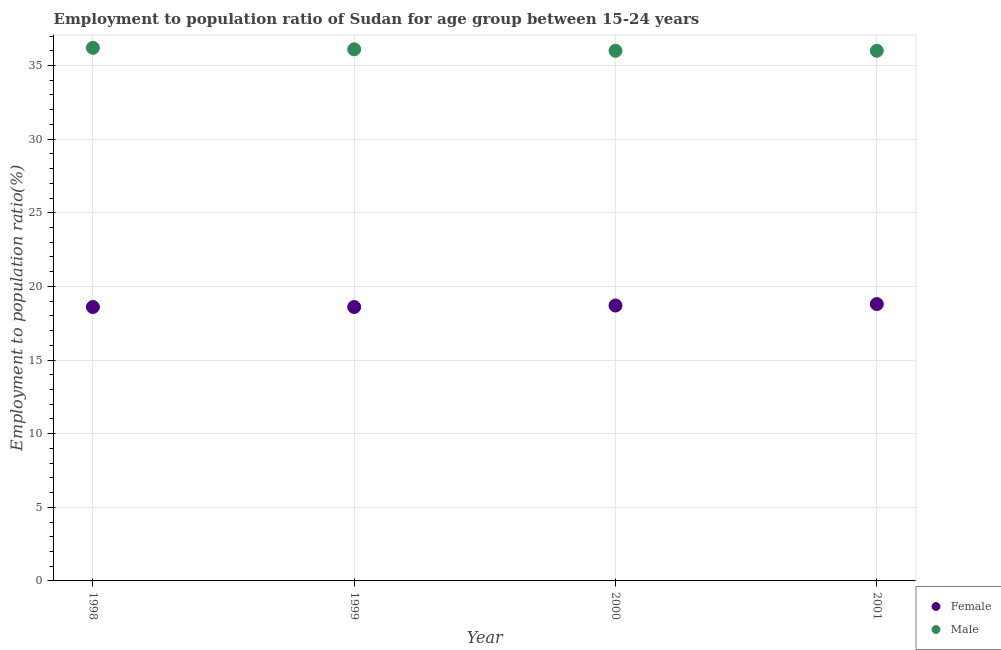How many different coloured dotlines are there?
Your response must be concise. 2. Is the number of dotlines equal to the number of legend labels?
Keep it short and to the point. Yes. What is the employment to population ratio(male) in 1999?
Your answer should be very brief. 36.1. Across all years, what is the maximum employment to population ratio(male)?
Make the answer very short. 36.2. Across all years, what is the minimum employment to population ratio(female)?
Keep it short and to the point. 18.6. What is the total employment to population ratio(male) in the graph?
Offer a very short reply. 144.3. What is the difference between the employment to population ratio(male) in 1999 and that in 2000?
Offer a very short reply. 0.1. What is the difference between the employment to population ratio(female) in 2001 and the employment to population ratio(male) in 2000?
Your answer should be very brief. -17.2. What is the average employment to population ratio(female) per year?
Offer a terse response. 18.68. In the year 2001, what is the difference between the employment to population ratio(male) and employment to population ratio(female)?
Your answer should be very brief. 17.2. What is the ratio of the employment to population ratio(female) in 1998 to that in 2000?
Your response must be concise. 0.99. Is the employment to population ratio(female) in 2000 less than that in 2001?
Your response must be concise. Yes. Is the difference between the employment to population ratio(female) in 1998 and 2001 greater than the difference between the employment to population ratio(male) in 1998 and 2001?
Your answer should be compact. No. What is the difference between the highest and the second highest employment to population ratio(male)?
Provide a succinct answer. 0.1. What is the difference between the highest and the lowest employment to population ratio(male)?
Make the answer very short. 0.2. Is the sum of the employment to population ratio(male) in 1999 and 2001 greater than the maximum employment to population ratio(female) across all years?
Ensure brevity in your answer.  Yes. What is the difference between two consecutive major ticks on the Y-axis?
Provide a succinct answer. 5. Are the values on the major ticks of Y-axis written in scientific E-notation?
Make the answer very short. No. Does the graph contain any zero values?
Make the answer very short. No. Does the graph contain grids?
Your answer should be very brief. Yes. How many legend labels are there?
Make the answer very short. 2. How are the legend labels stacked?
Give a very brief answer. Vertical. What is the title of the graph?
Your response must be concise. Employment to population ratio of Sudan for age group between 15-24 years. What is the label or title of the X-axis?
Your answer should be compact. Year. What is the label or title of the Y-axis?
Your answer should be very brief. Employment to population ratio(%). What is the Employment to population ratio(%) in Female in 1998?
Provide a succinct answer. 18.6. What is the Employment to population ratio(%) of Male in 1998?
Make the answer very short. 36.2. What is the Employment to population ratio(%) of Female in 1999?
Offer a terse response. 18.6. What is the Employment to population ratio(%) in Male in 1999?
Provide a short and direct response. 36.1. What is the Employment to population ratio(%) of Female in 2000?
Make the answer very short. 18.7. What is the Employment to population ratio(%) of Female in 2001?
Give a very brief answer. 18.8. Across all years, what is the maximum Employment to population ratio(%) in Female?
Make the answer very short. 18.8. Across all years, what is the maximum Employment to population ratio(%) of Male?
Keep it short and to the point. 36.2. Across all years, what is the minimum Employment to population ratio(%) of Female?
Offer a very short reply. 18.6. What is the total Employment to population ratio(%) in Female in the graph?
Offer a terse response. 74.7. What is the total Employment to population ratio(%) in Male in the graph?
Provide a short and direct response. 144.3. What is the difference between the Employment to population ratio(%) in Female in 1998 and that in 1999?
Keep it short and to the point. 0. What is the difference between the Employment to population ratio(%) of Female in 1999 and that in 2000?
Your answer should be very brief. -0.1. What is the difference between the Employment to population ratio(%) in Male in 1999 and that in 2000?
Your response must be concise. 0.1. What is the difference between the Employment to population ratio(%) of Female in 2000 and that in 2001?
Make the answer very short. -0.1. What is the difference between the Employment to population ratio(%) of Female in 1998 and the Employment to population ratio(%) of Male in 1999?
Offer a very short reply. -17.5. What is the difference between the Employment to population ratio(%) of Female in 1998 and the Employment to population ratio(%) of Male in 2000?
Offer a terse response. -17.4. What is the difference between the Employment to population ratio(%) in Female in 1998 and the Employment to population ratio(%) in Male in 2001?
Ensure brevity in your answer.  -17.4. What is the difference between the Employment to population ratio(%) of Female in 1999 and the Employment to population ratio(%) of Male in 2000?
Your answer should be compact. -17.4. What is the difference between the Employment to population ratio(%) of Female in 1999 and the Employment to population ratio(%) of Male in 2001?
Offer a terse response. -17.4. What is the difference between the Employment to population ratio(%) in Female in 2000 and the Employment to population ratio(%) in Male in 2001?
Offer a very short reply. -17.3. What is the average Employment to population ratio(%) of Female per year?
Offer a terse response. 18.68. What is the average Employment to population ratio(%) of Male per year?
Provide a short and direct response. 36.08. In the year 1998, what is the difference between the Employment to population ratio(%) of Female and Employment to population ratio(%) of Male?
Ensure brevity in your answer.  -17.6. In the year 1999, what is the difference between the Employment to population ratio(%) in Female and Employment to population ratio(%) in Male?
Keep it short and to the point. -17.5. In the year 2000, what is the difference between the Employment to population ratio(%) of Female and Employment to population ratio(%) of Male?
Give a very brief answer. -17.3. In the year 2001, what is the difference between the Employment to population ratio(%) in Female and Employment to population ratio(%) in Male?
Provide a succinct answer. -17.2. What is the ratio of the Employment to population ratio(%) in Male in 1998 to that in 2000?
Your answer should be compact. 1.01. What is the ratio of the Employment to population ratio(%) in Male in 1998 to that in 2001?
Provide a short and direct response. 1.01. What is the ratio of the Employment to population ratio(%) in Female in 1999 to that in 2001?
Your answer should be very brief. 0.99. What is the ratio of the Employment to population ratio(%) in Male in 2000 to that in 2001?
Your response must be concise. 1. What is the difference between the highest and the second highest Employment to population ratio(%) of Male?
Give a very brief answer. 0.1. What is the difference between the highest and the lowest Employment to population ratio(%) of Male?
Your answer should be very brief. 0.2. 